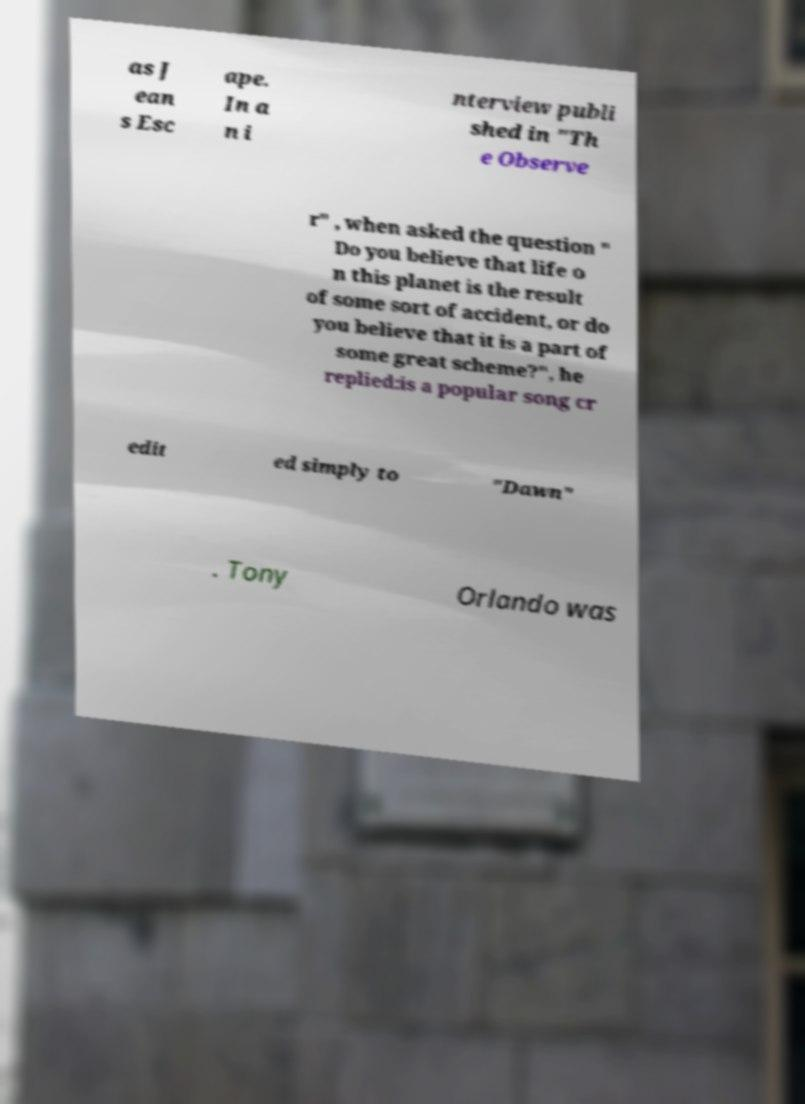Please read and relay the text visible in this image. What does it say? as J ean s Esc ape. In a n i nterview publi shed in "Th e Observe r" , when asked the question " Do you believe that life o n this planet is the result of some sort of accident, or do you believe that it is a part of some great scheme?", he replied:is a popular song cr edit ed simply to "Dawn" . Tony Orlando was 